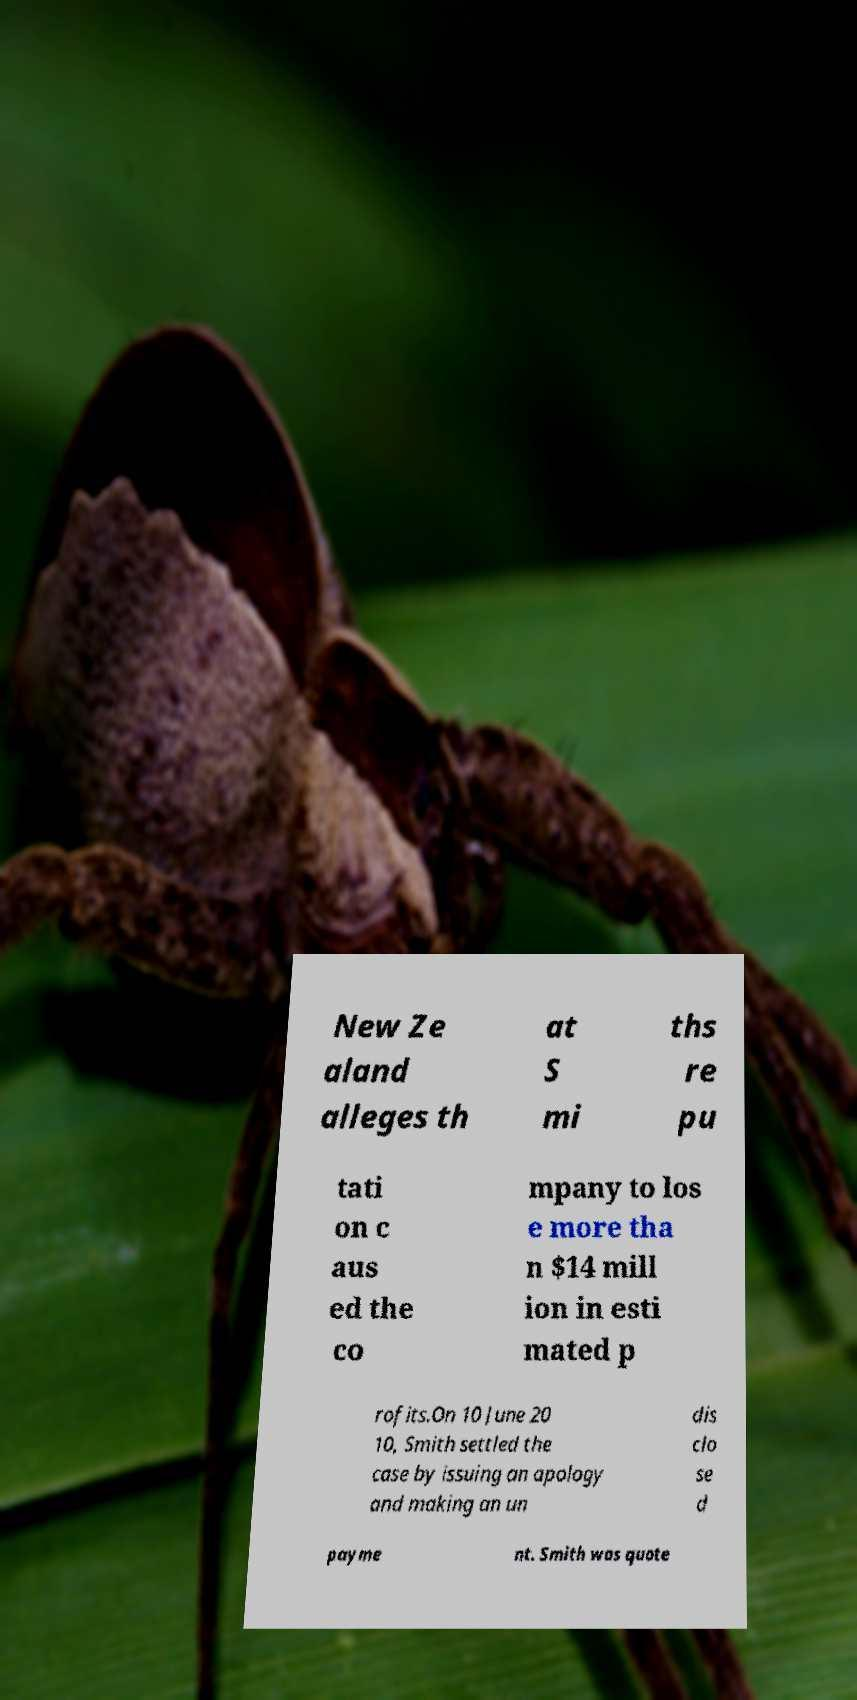What messages or text are displayed in this image? I need them in a readable, typed format. New Ze aland alleges th at S mi ths re pu tati on c aus ed the co mpany to los e more tha n $14 mill ion in esti mated p rofits.On 10 June 20 10, Smith settled the case by issuing an apology and making an un dis clo se d payme nt. Smith was quote 